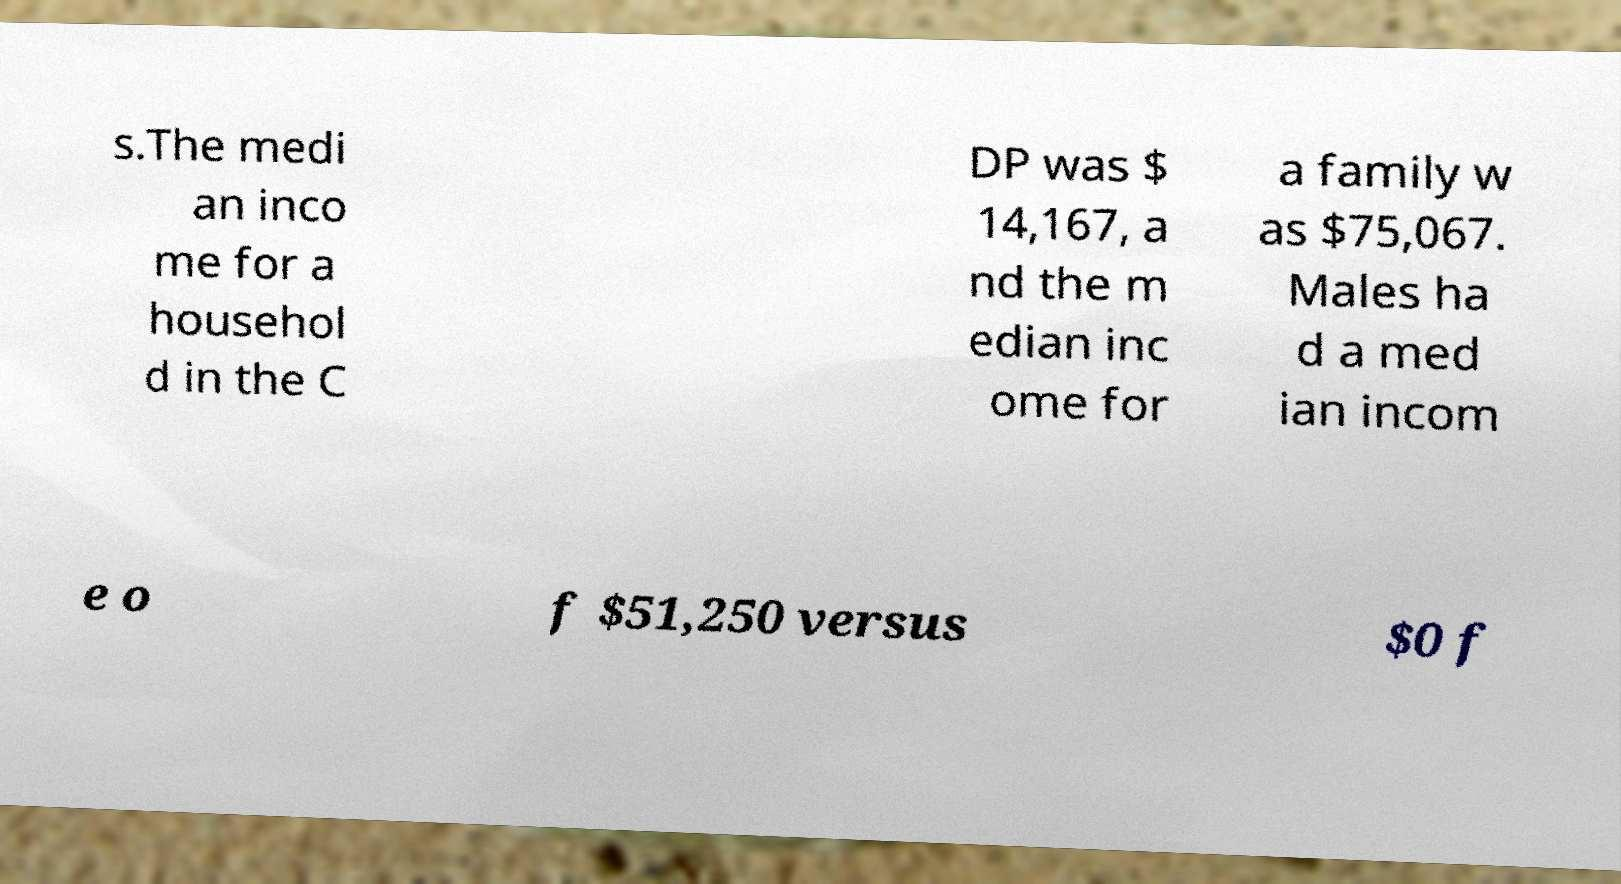For documentation purposes, I need the text within this image transcribed. Could you provide that? s.The medi an inco me for a househol d in the C DP was $ 14,167, a nd the m edian inc ome for a family w as $75,067. Males ha d a med ian incom e o f $51,250 versus $0 f 